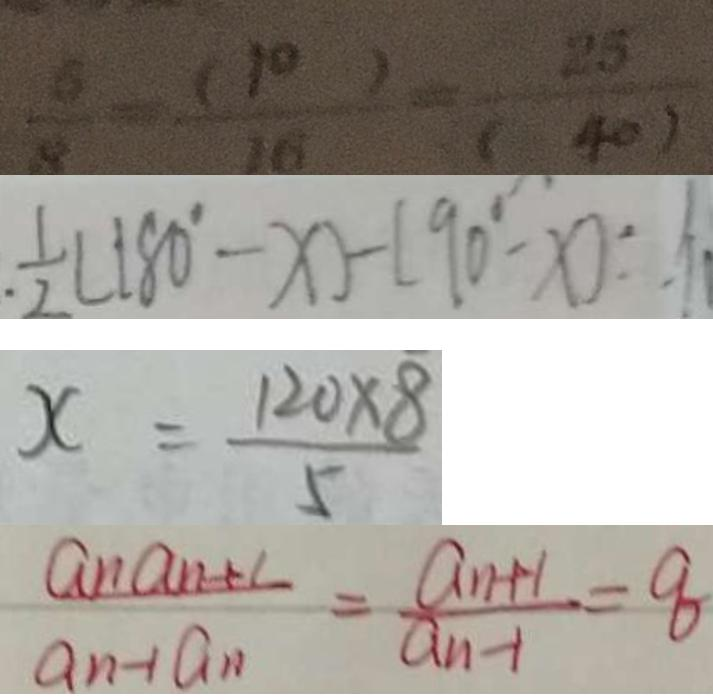<formula> <loc_0><loc_0><loc_500><loc_500>\frac { 6 } { 8 } = \frac { ( 1 0 ) } { 1 6 } = \frac { 2 5 } { ( 4 0 ) } 
 . \frac { 1 } { 2 } ( 1 8 0 ^ { \circ } - x ) - ( 9 0 ^ { \circ } - x ) : 
 x = \frac { 1 2 0 \times 8 } { 5 } 
 \frac { a _ { n } a _ { n + 1 } } { a _ { n } - 1 a _ { n } } = \frac { a _ { n + 1 } } { a _ { n - 1 } } = 8</formula> 